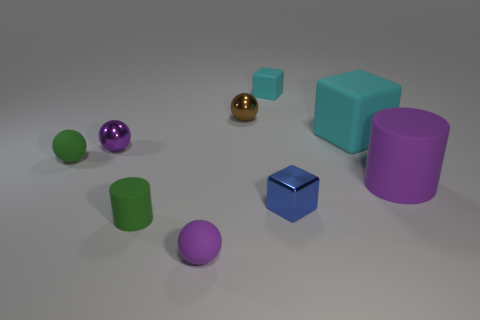Are there any patterns or symmetry in the arrangement of the objects? There seems to be no intentional pattern or symmetry in the placement of the objects. The objects are scattered randomly across the surface with varying distances between them, creating an arbitrary and natural-looking arrangement. 